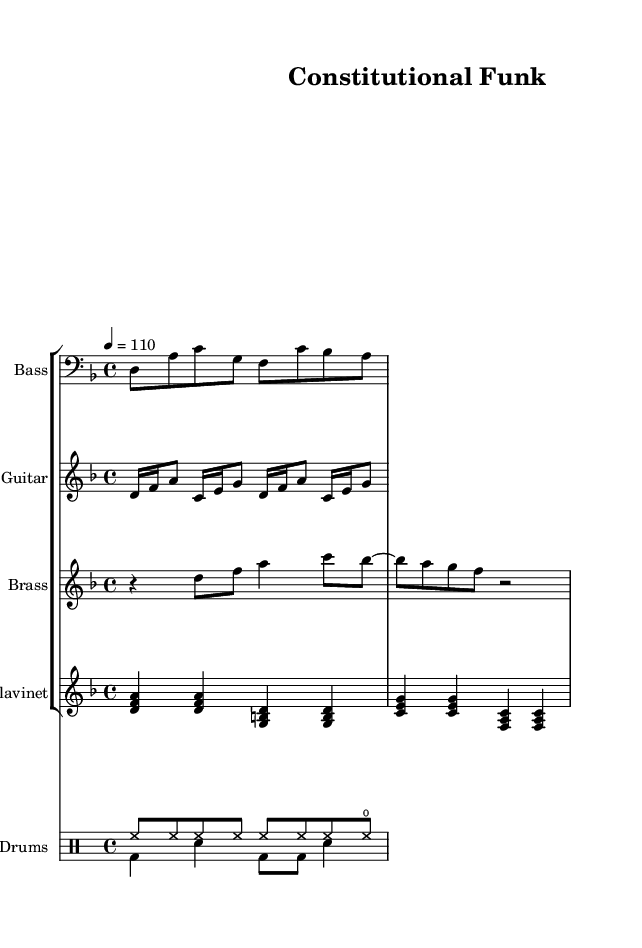What is the key signature of this music? The music is in the key of D minor, indicated by one flat in the key signature (B flat).
Answer: D minor What is the time signature of this piece? The time signature is 4/4, meaning there are four beats in a measure. This is commonly found in funk music for a steady and danceable groove.
Answer: 4/4 What is the tempo marking for this piece? The tempo marking is provided as 4 = 110, meaning there are 110 beats per minute. This tempo creates an upbeat and lively feel, typical of funk.
Answer: 110 How many distinct instruments are featured in the score? The score features five distinct instruments: Bass, Guitar, Brass, Clavinet, and Drums. Each instrument has its own staff for clarity.
Answer: Five What type of musical form does the piece utilize? The piece utilizes a verse-chorus form, as indicated by the presence of verses and chorus lyrics that suggest a repeating structure typical in funk music.
Answer: Verse-Chorus What rhythmic pattern is primarily used in the drum part? The drum part predominantly features eighth notes on the hi-hat and a bass drum pattern that emphasizes the backbeat, which is characteristic of funk music.
Answer: Eighth notes What is the primary theme expressed in the lyrics? The primary theme expressed in the lyrics is the evolution of constitutional law, indicating a celebration of freedom and its historical context through the groove of the music.
Answer: Evolution of constitutional law 